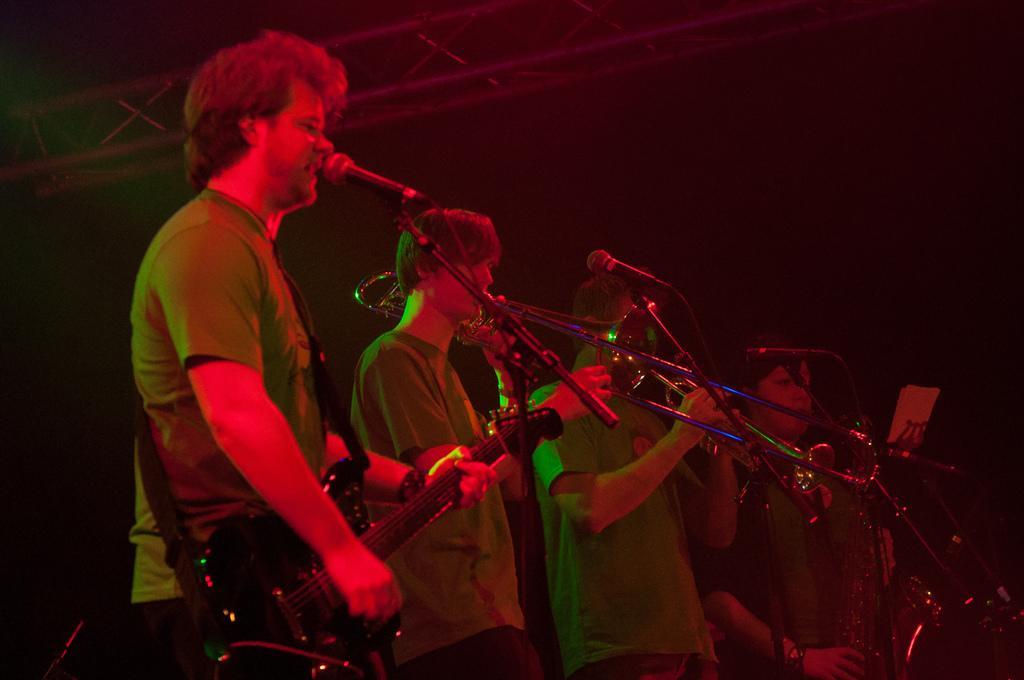Could you give a brief overview of what you see in this image? There are four persons, playing musical instruments and singing in front of mics which are attached to the stands, on a stage. In the background, there is a roof and the background is dark in color. 